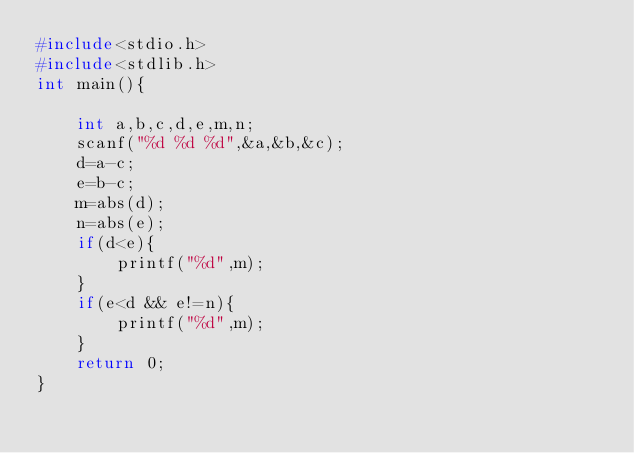Convert code to text. <code><loc_0><loc_0><loc_500><loc_500><_C_>#include<stdio.h>
#include<stdlib.h>
int main(){

    int a,b,c,d,e,m,n;
    scanf("%d %d %d",&a,&b,&c);
    d=a-c;
    e=b-c;
    m=abs(d);
    n=abs(e);
    if(d<e){
        printf("%d",m);
    }
    if(e<d && e!=n){
        printf("%d",m);
    }
    return 0;
}
</code> 